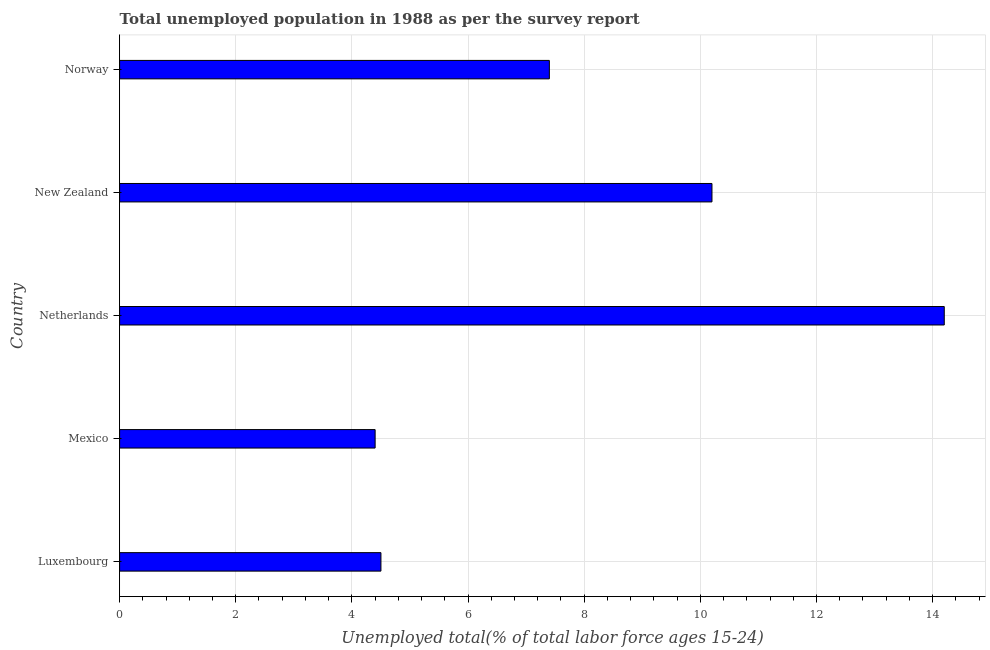What is the title of the graph?
Give a very brief answer. Total unemployed population in 1988 as per the survey report. What is the label or title of the X-axis?
Keep it short and to the point. Unemployed total(% of total labor force ages 15-24). What is the unemployed youth in Norway?
Ensure brevity in your answer.  7.4. Across all countries, what is the maximum unemployed youth?
Your answer should be very brief. 14.2. Across all countries, what is the minimum unemployed youth?
Make the answer very short. 4.4. In which country was the unemployed youth maximum?
Your answer should be compact. Netherlands. In which country was the unemployed youth minimum?
Make the answer very short. Mexico. What is the sum of the unemployed youth?
Keep it short and to the point. 40.7. What is the difference between the unemployed youth in Mexico and Netherlands?
Offer a terse response. -9.8. What is the average unemployed youth per country?
Keep it short and to the point. 8.14. What is the median unemployed youth?
Make the answer very short. 7.4. In how many countries, is the unemployed youth greater than 11.2 %?
Offer a very short reply. 1. What is the ratio of the unemployed youth in Luxembourg to that in Norway?
Provide a succinct answer. 0.61. Is the difference between the unemployed youth in Mexico and New Zealand greater than the difference between any two countries?
Ensure brevity in your answer.  No. Is the sum of the unemployed youth in Netherlands and New Zealand greater than the maximum unemployed youth across all countries?
Give a very brief answer. Yes. What is the difference between the highest and the lowest unemployed youth?
Offer a terse response. 9.8. In how many countries, is the unemployed youth greater than the average unemployed youth taken over all countries?
Offer a terse response. 2. What is the difference between two consecutive major ticks on the X-axis?
Your answer should be compact. 2. Are the values on the major ticks of X-axis written in scientific E-notation?
Make the answer very short. No. What is the Unemployed total(% of total labor force ages 15-24) of Luxembourg?
Keep it short and to the point. 4.5. What is the Unemployed total(% of total labor force ages 15-24) of Mexico?
Your answer should be very brief. 4.4. What is the Unemployed total(% of total labor force ages 15-24) of Netherlands?
Make the answer very short. 14.2. What is the Unemployed total(% of total labor force ages 15-24) of New Zealand?
Offer a terse response. 10.2. What is the Unemployed total(% of total labor force ages 15-24) in Norway?
Ensure brevity in your answer.  7.4. What is the difference between the Unemployed total(% of total labor force ages 15-24) in Mexico and Netherlands?
Ensure brevity in your answer.  -9.8. What is the difference between the Unemployed total(% of total labor force ages 15-24) in Mexico and Norway?
Provide a succinct answer. -3. What is the difference between the Unemployed total(% of total labor force ages 15-24) in New Zealand and Norway?
Offer a very short reply. 2.8. What is the ratio of the Unemployed total(% of total labor force ages 15-24) in Luxembourg to that in Mexico?
Provide a short and direct response. 1.02. What is the ratio of the Unemployed total(% of total labor force ages 15-24) in Luxembourg to that in Netherlands?
Your answer should be compact. 0.32. What is the ratio of the Unemployed total(% of total labor force ages 15-24) in Luxembourg to that in New Zealand?
Provide a succinct answer. 0.44. What is the ratio of the Unemployed total(% of total labor force ages 15-24) in Luxembourg to that in Norway?
Ensure brevity in your answer.  0.61. What is the ratio of the Unemployed total(% of total labor force ages 15-24) in Mexico to that in Netherlands?
Your answer should be very brief. 0.31. What is the ratio of the Unemployed total(% of total labor force ages 15-24) in Mexico to that in New Zealand?
Make the answer very short. 0.43. What is the ratio of the Unemployed total(% of total labor force ages 15-24) in Mexico to that in Norway?
Offer a very short reply. 0.59. What is the ratio of the Unemployed total(% of total labor force ages 15-24) in Netherlands to that in New Zealand?
Make the answer very short. 1.39. What is the ratio of the Unemployed total(% of total labor force ages 15-24) in Netherlands to that in Norway?
Provide a succinct answer. 1.92. What is the ratio of the Unemployed total(% of total labor force ages 15-24) in New Zealand to that in Norway?
Provide a short and direct response. 1.38. 